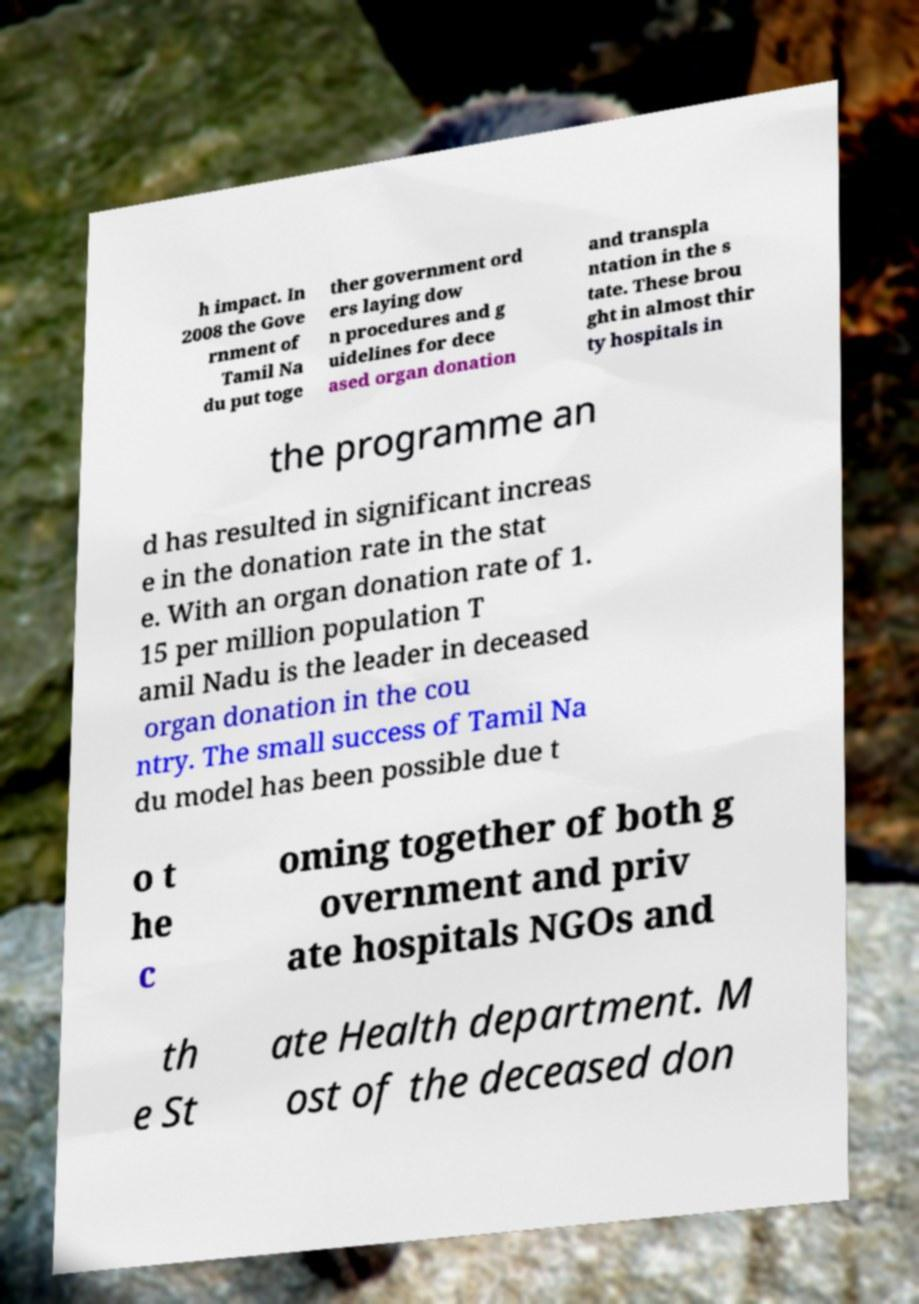There's text embedded in this image that I need extracted. Can you transcribe it verbatim? h impact. In 2008 the Gove rnment of Tamil Na du put toge ther government ord ers laying dow n procedures and g uidelines for dece ased organ donation and transpla ntation in the s tate. These brou ght in almost thir ty hospitals in the programme an d has resulted in significant increas e in the donation rate in the stat e. With an organ donation rate of 1. 15 per million population T amil Nadu is the leader in deceased organ donation in the cou ntry. The small success of Tamil Na du model has been possible due t o t he c oming together of both g overnment and priv ate hospitals NGOs and th e St ate Health department. M ost of the deceased don 